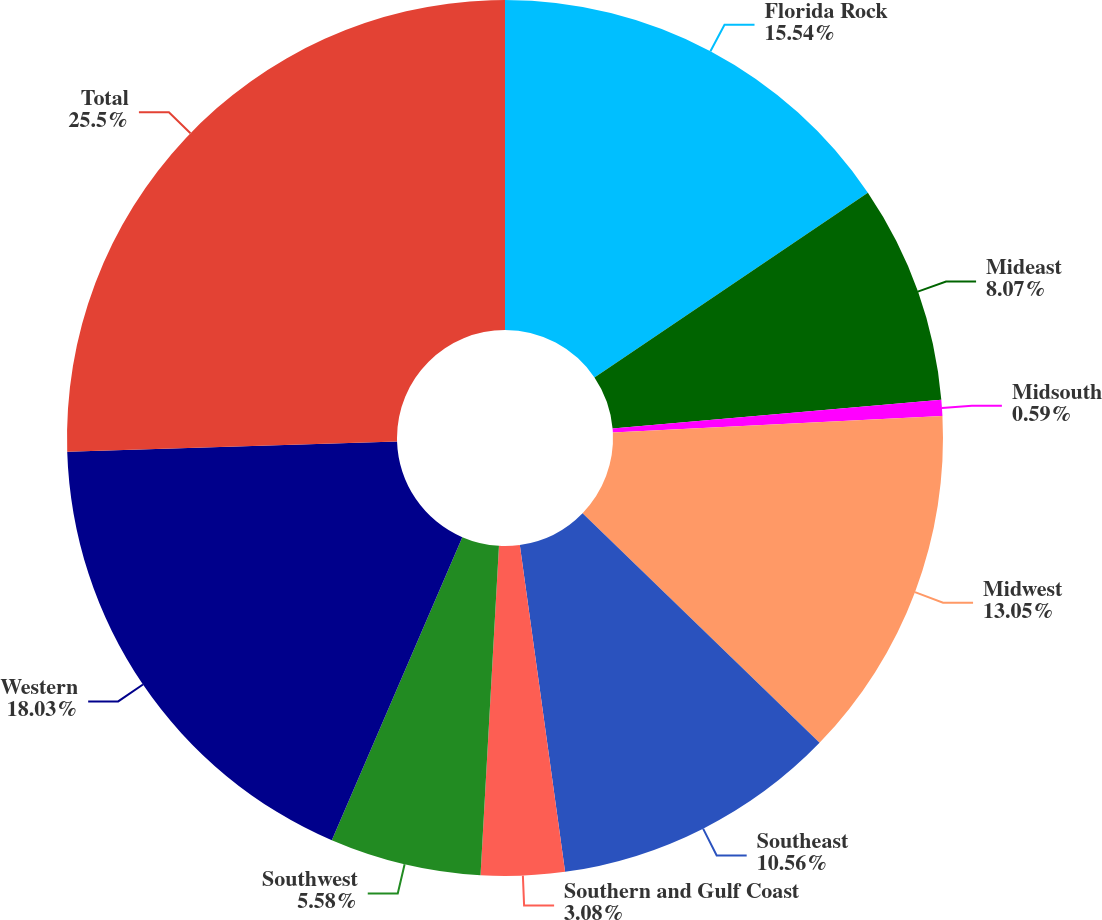<chart> <loc_0><loc_0><loc_500><loc_500><pie_chart><fcel>Florida Rock<fcel>Mideast<fcel>Midsouth<fcel>Midwest<fcel>Southeast<fcel>Southern and Gulf Coast<fcel>Southwest<fcel>Western<fcel>Total<nl><fcel>15.54%<fcel>8.07%<fcel>0.59%<fcel>13.05%<fcel>10.56%<fcel>3.08%<fcel>5.58%<fcel>18.03%<fcel>25.5%<nl></chart> 